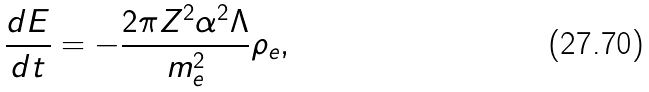Convert formula to latex. <formula><loc_0><loc_0><loc_500><loc_500>\frac { d E } { d t } = - \frac { 2 \pi Z ^ { 2 } \alpha ^ { 2 } \Lambda } { m _ { e } ^ { 2 } } \rho _ { e } ,</formula> 